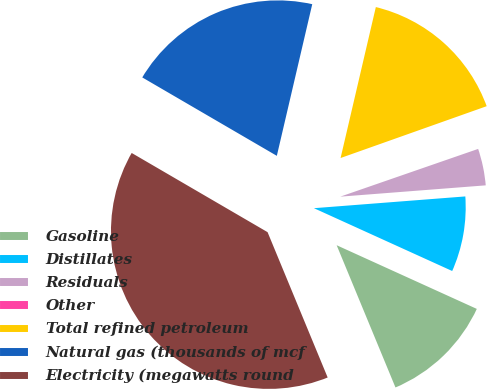<chart> <loc_0><loc_0><loc_500><loc_500><pie_chart><fcel>Gasoline<fcel>Distillates<fcel>Residuals<fcel>Other<fcel>Total refined petroleum<fcel>Natural gas (thousands of mcf<fcel>Electricity (megawatts round<nl><fcel>11.97%<fcel>8.02%<fcel>4.07%<fcel>0.12%<fcel>15.92%<fcel>20.25%<fcel>39.63%<nl></chart> 